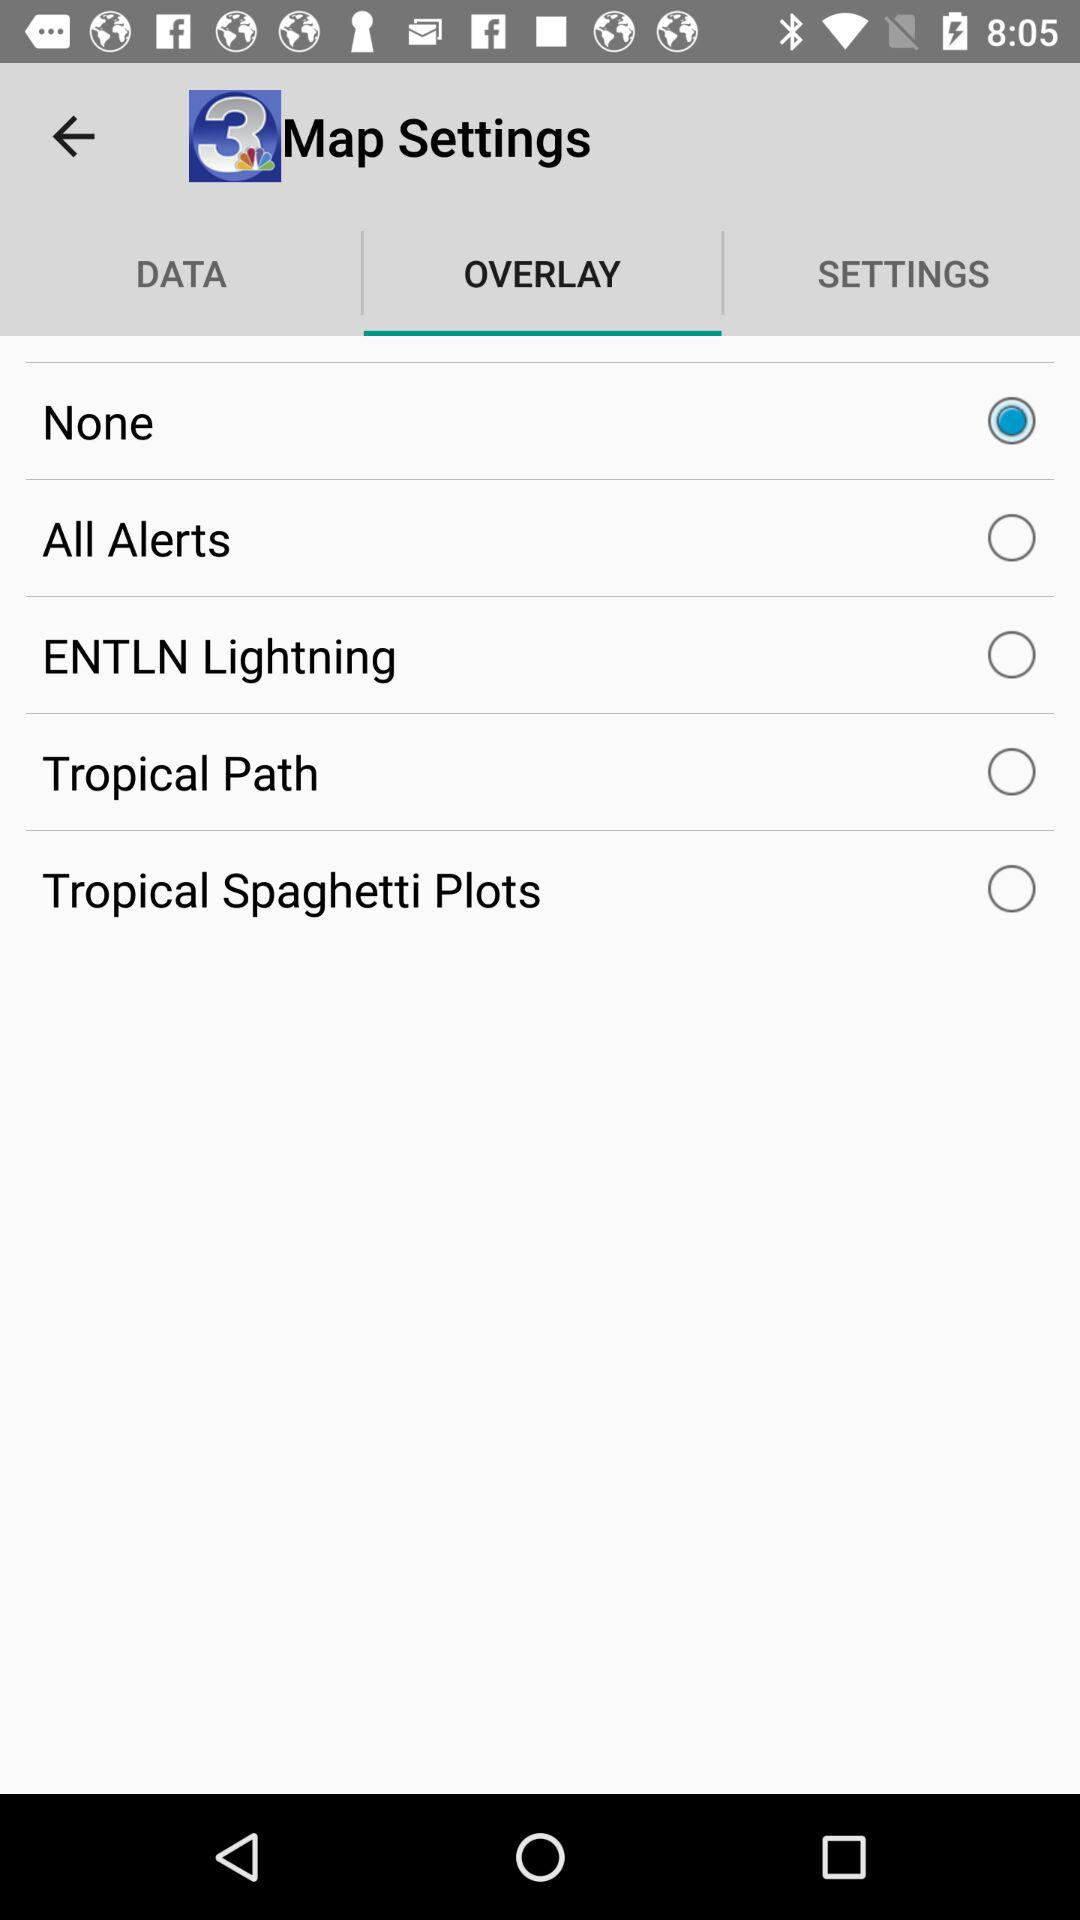Which radio button is selected? The selected radio button is "None". 